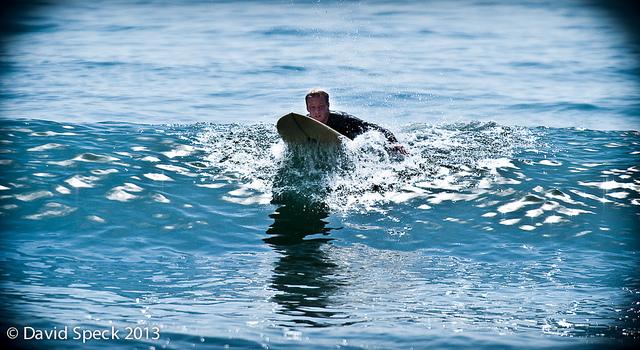What is the foamy stuff called?
Concise answer only. Surf. Is the man wet?
Answer briefly. Yes. What color is the water?
Concise answer only. Blue. 